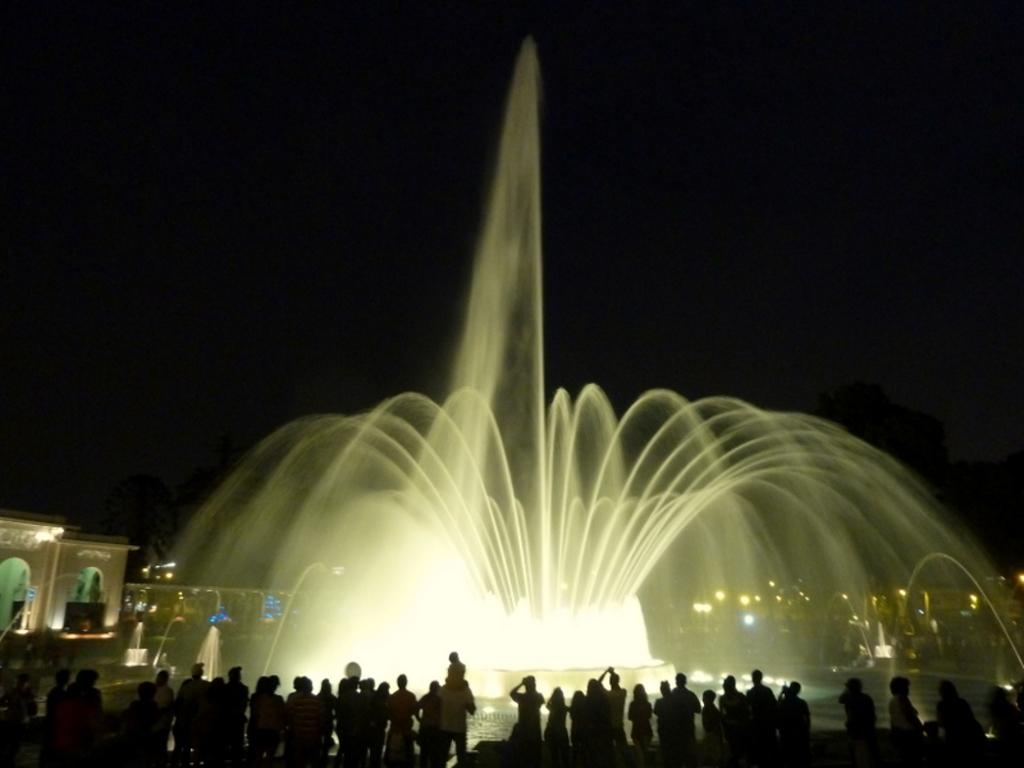What is happening in the image involving a group of people? There is a group of people standing in the image. What is another feature present in the image? There is a water fountain in the image. Are there any other elements visible in the image? Yes, there are lights in the image. How would you describe the overall appearance of the image? The background of the image is dark. What type of activity are the people engaged in during their voyage in the image? There is no indication of a voyage or any specific activity involving the people in the image; they are simply standing. What type of talk is being given by the people in the image? There is no talk or speech being given by the people in the image; they are standing silently. 